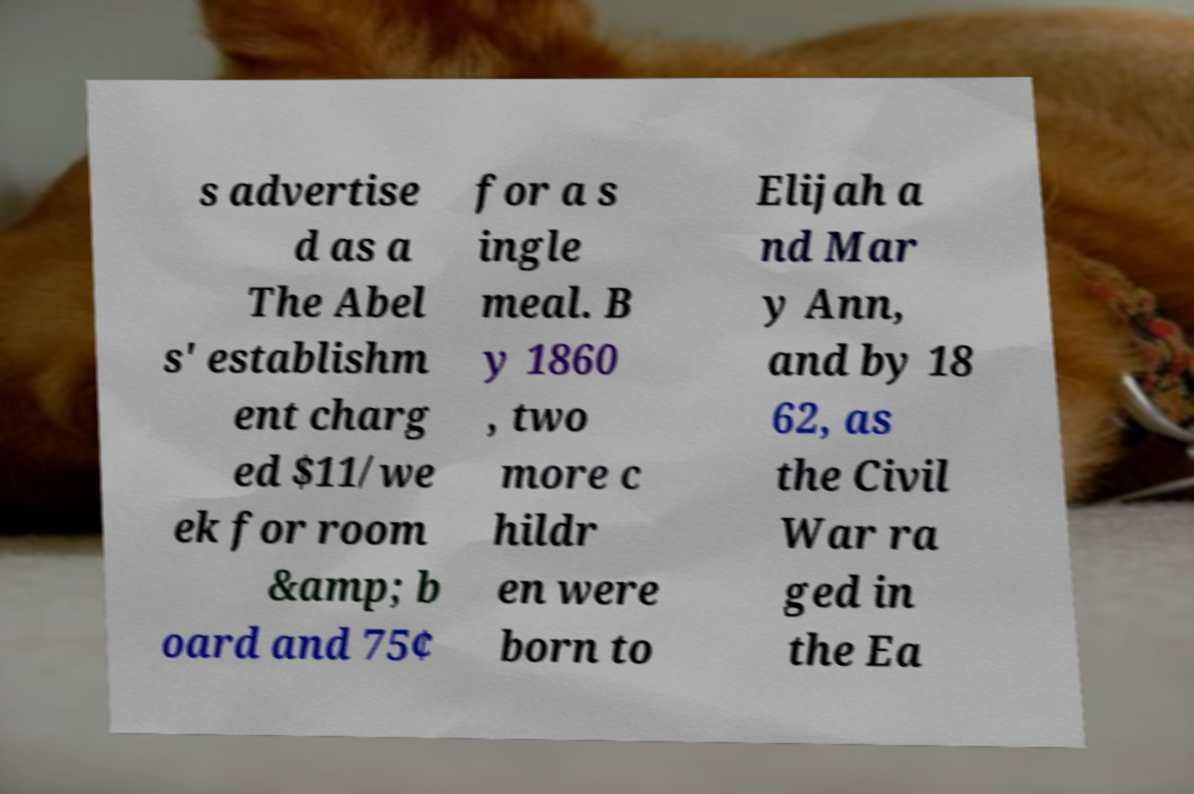Please identify and transcribe the text found in this image. s advertise d as a The Abel s' establishm ent charg ed $11/we ek for room &amp; b oard and 75¢ for a s ingle meal. B y 1860 , two more c hildr en were born to Elijah a nd Mar y Ann, and by 18 62, as the Civil War ra ged in the Ea 